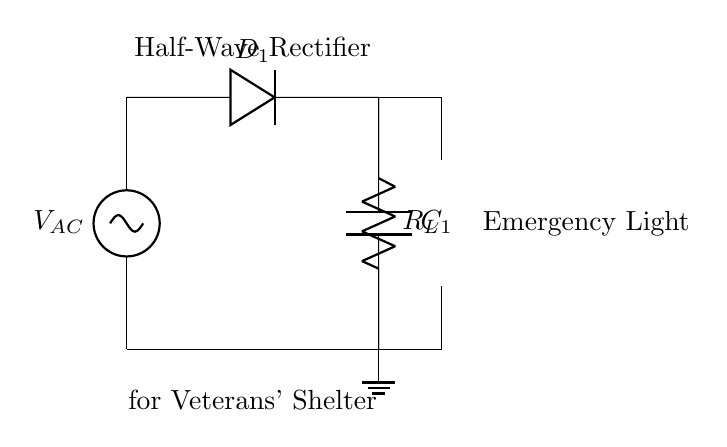What is the type of rectifier in this circuit? The circuit shows a half-wave rectifier, which only allows one half of the AC waveform to pass through while blocking the other half. This is indicated by the presence of a single diode.
Answer: Half-wave rectifier What is the purpose of the diode in the circuit? The diode allows current to flow in one direction only, converting AC voltage to DC voltage by blocking the negative portion of the AC signal. This function is critical in providing the necessary power to the load.
Answer: Convert AC to DC What component is used to smooth the output voltage? The capacitor is used to smooth the pulsed output voltage generated after rectification, helping to reduce voltage fluctuations. Its placement after the load indicates its role in filtering and stabilizing the output.
Answer: Capacitor What is the function of the load resistor in the circuit? The load resistor represents the load that the circuit powers, facilitating the use of the rectified voltage to operate the emergency light. It plays a key role in controlling the current that flows through the circuit based on its resistance value.
Answer: Load resistor How many diodes are in this rectifier circuit? There is one diode present in the circuit diagram, which is sufficient for a half-wave rectification process as it only needs to allow one half of the AC waveform to pass through.
Answer: One What is the voltage across the emergency light when powered? The voltage across the emergency light is the rectified voltage, which is equal to the peak value of the AC supply voltage minus the forward voltage drop of the diode during conduction.
Answer: Peak voltage minus diode drop What is the overall application of this half-wave rectifier circuit? This circuit is designed to provide power to emergency lighting systems specifically in veterans' shelters, ensuring that lights can function during power outages or emergencies.
Answer: Emergency lighting system 